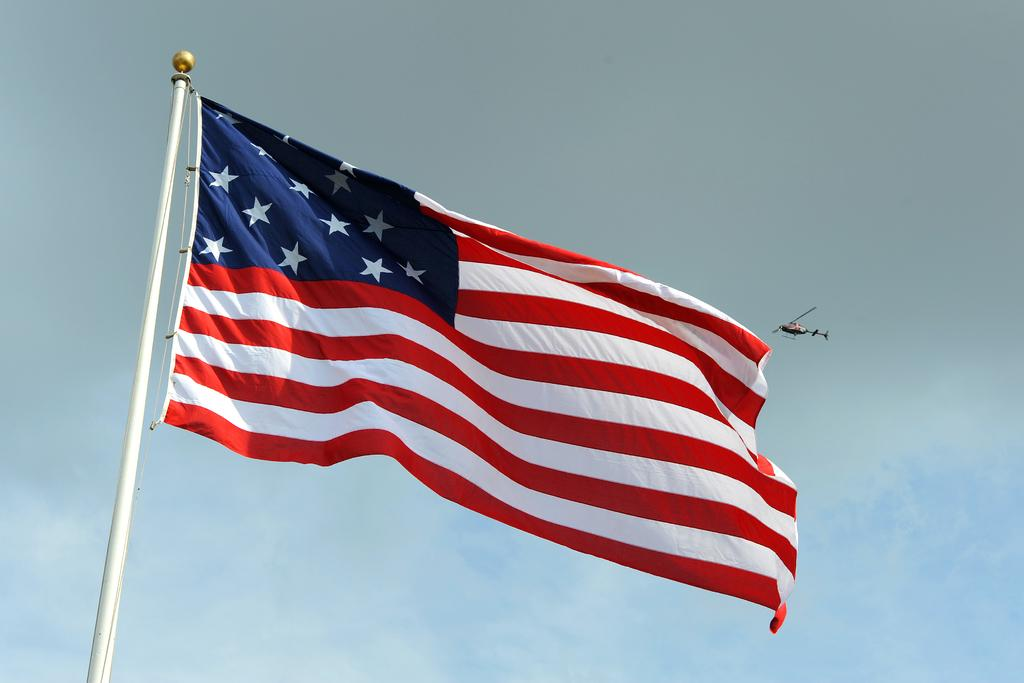What can be seen in the image that represents a symbol or country? There is a flag in the image. What type of vehicle is flying in the image? There is a helicopter flying in the image. What part of the natural environment is visible in the image? The sky is visible in the background of the image. Can you tell me how many times the beast sneezes in the image? There is no beast or sneezing present in the image. What type of receipt can be seen in the image? There is no receipt present in the image. 